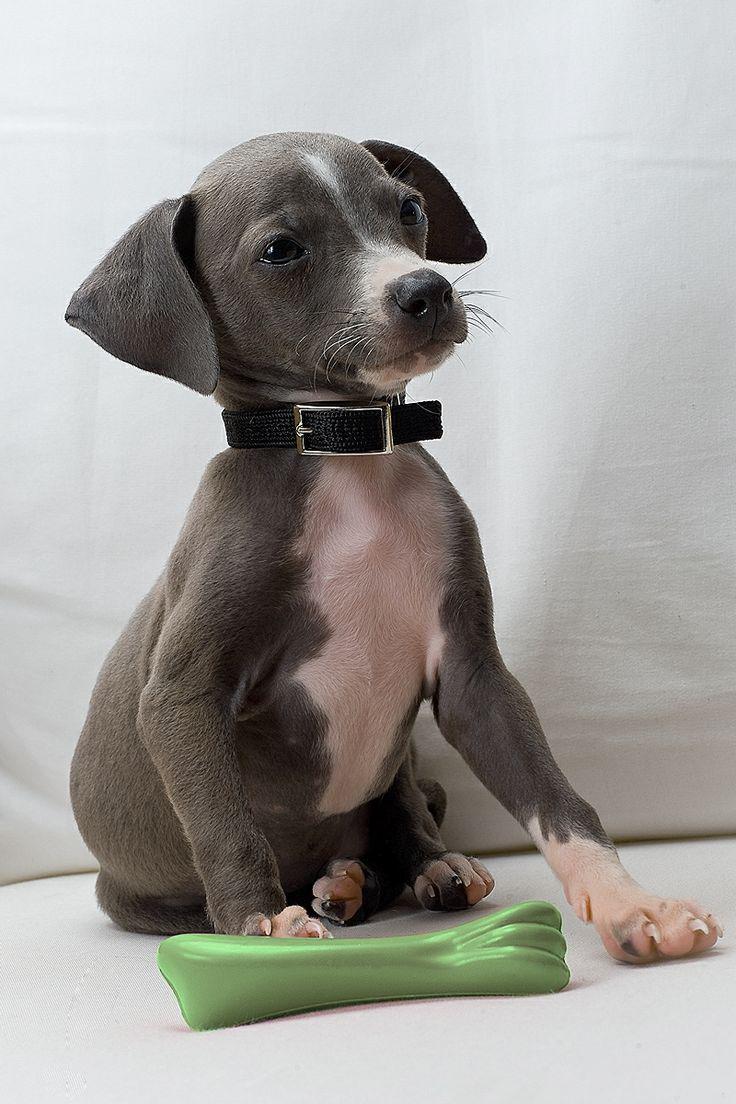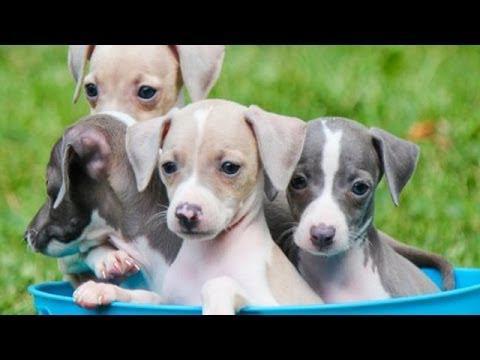The first image is the image on the left, the second image is the image on the right. Considering the images on both sides, is "An image shows at least three dogs inside some type of container." valid? Answer yes or no. Yes. 